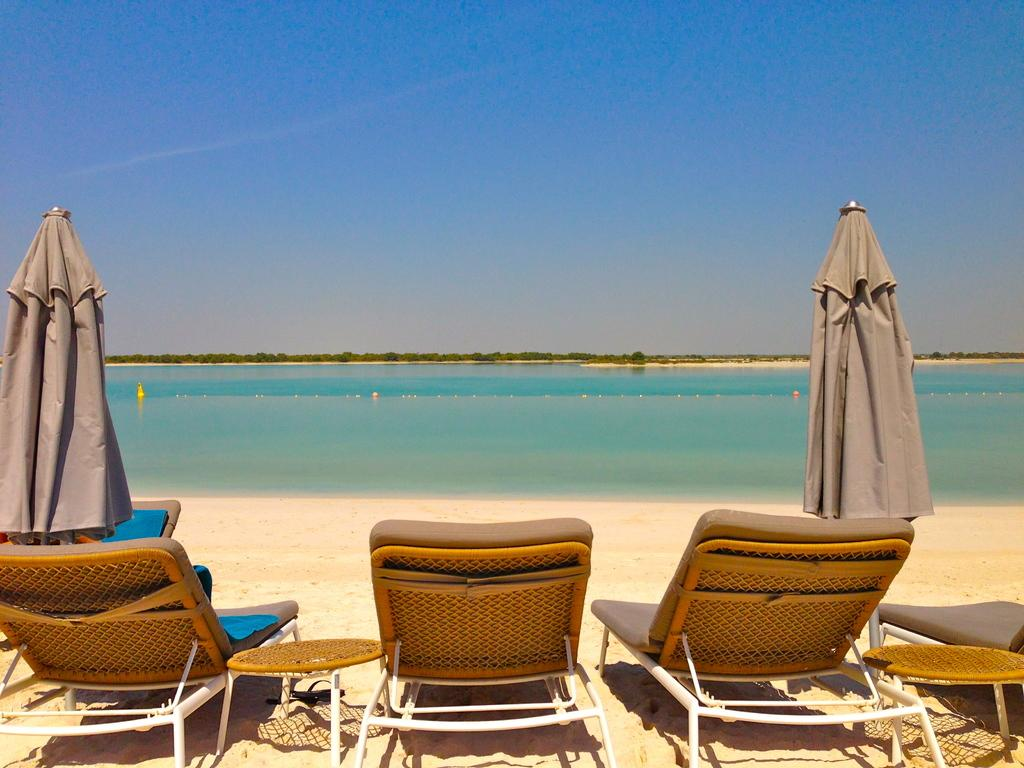What type of furniture is located at the bottom of the image? There are chaise lounges at the bottom of the image. What other objects can be seen at the bottom of the image? There are stands and parasols at the bottom of the image. What is visible in the background of the image? There is a sea and sky visible in the background of the image. What type of stone is used to make the bells in the image? There are no bells present in the image, so it is not possible to determine the type of stone used to make them. 